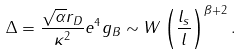Convert formula to latex. <formula><loc_0><loc_0><loc_500><loc_500>\Delta = \frac { \sqrt { \alpha } r _ { D } } { \kappa ^ { 2 } } e ^ { 4 } g _ { B } \sim W \left ( \frac { l _ { s } } { l } \right ) ^ { \beta + 2 } .</formula> 